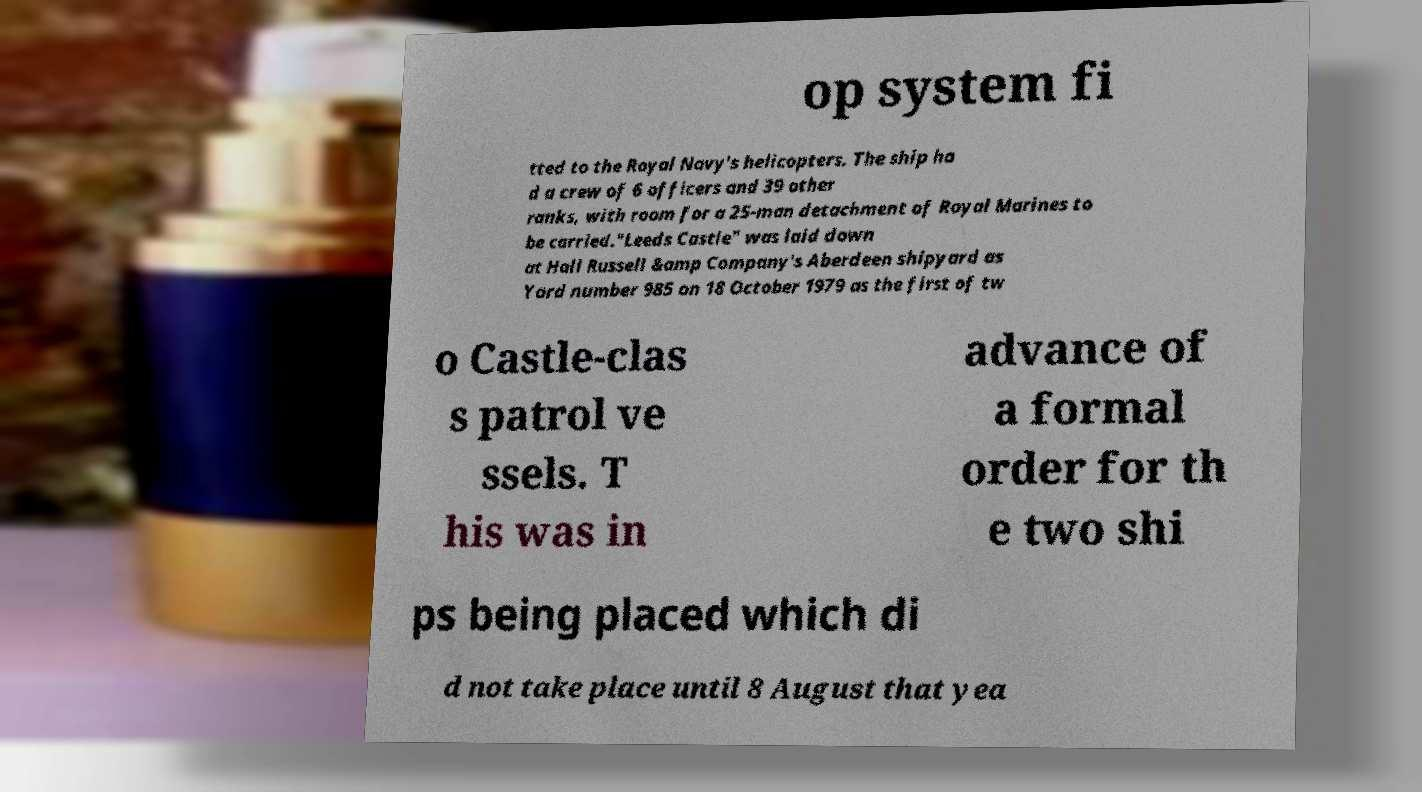There's text embedded in this image that I need extracted. Can you transcribe it verbatim? op system fi tted to the Royal Navy's helicopters. The ship ha d a crew of 6 officers and 39 other ranks, with room for a 25-man detachment of Royal Marines to be carried."Leeds Castle" was laid down at Hall Russell &amp Company's Aberdeen shipyard as Yard number 985 on 18 October 1979 as the first of tw o Castle-clas s patrol ve ssels. T his was in advance of a formal order for th e two shi ps being placed which di d not take place until 8 August that yea 